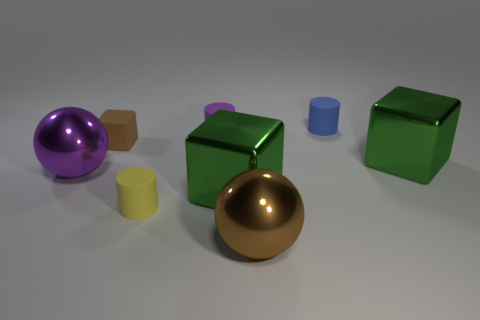Is there a cyan rubber thing that has the same shape as the blue object?
Your answer should be compact. No. What material is the large sphere that is the same color as the tiny block?
Offer a terse response. Metal. How many shiny things are either yellow cylinders or spheres?
Give a very brief answer. 2. What is the shape of the purple matte object?
Your answer should be compact. Cylinder. What number of big objects are made of the same material as the brown sphere?
Make the answer very short. 3. What is the color of the small cube that is made of the same material as the small yellow cylinder?
Give a very brief answer. Brown. There is a brown thing to the right of the purple matte cylinder; is it the same size as the blue thing?
Offer a very short reply. No. The other big object that is the same shape as the big purple object is what color?
Give a very brief answer. Brown. There is a brown thing that is behind the green block that is on the right side of the green shiny block left of the small blue rubber cylinder; what shape is it?
Provide a short and direct response. Cube. Does the large brown thing have the same shape as the purple shiny object?
Your answer should be very brief. Yes. 